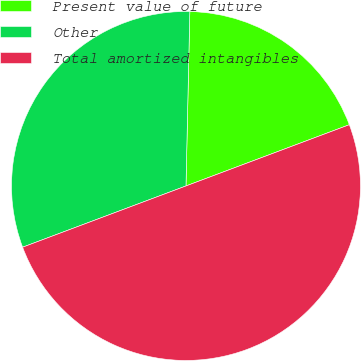Convert chart to OTSL. <chart><loc_0><loc_0><loc_500><loc_500><pie_chart><fcel>Present value of future<fcel>Other<fcel>Total amortized intangibles<nl><fcel>18.94%<fcel>31.06%<fcel>50.0%<nl></chart> 